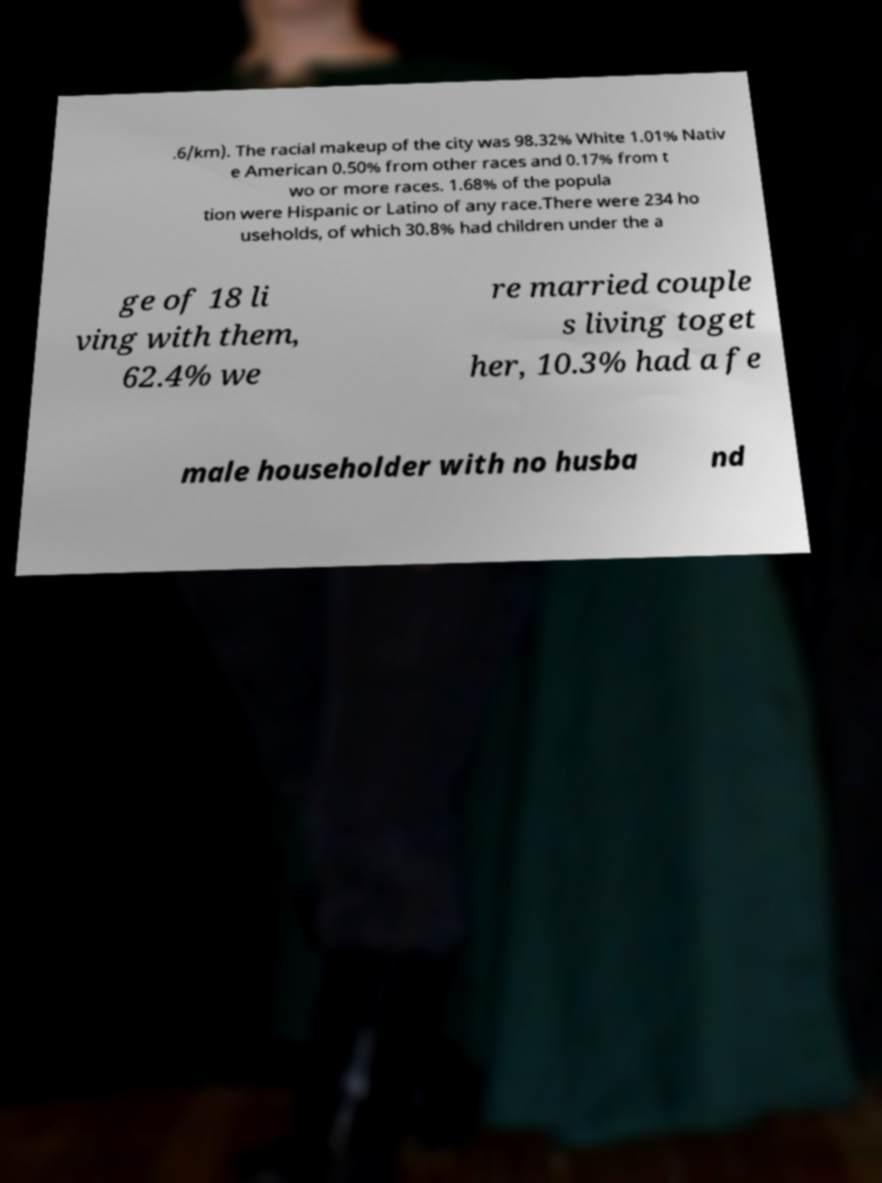There's text embedded in this image that I need extracted. Can you transcribe it verbatim? .6/km). The racial makeup of the city was 98.32% White 1.01% Nativ e American 0.50% from other races and 0.17% from t wo or more races. 1.68% of the popula tion were Hispanic or Latino of any race.There were 234 ho useholds, of which 30.8% had children under the a ge of 18 li ving with them, 62.4% we re married couple s living toget her, 10.3% had a fe male householder with no husba nd 